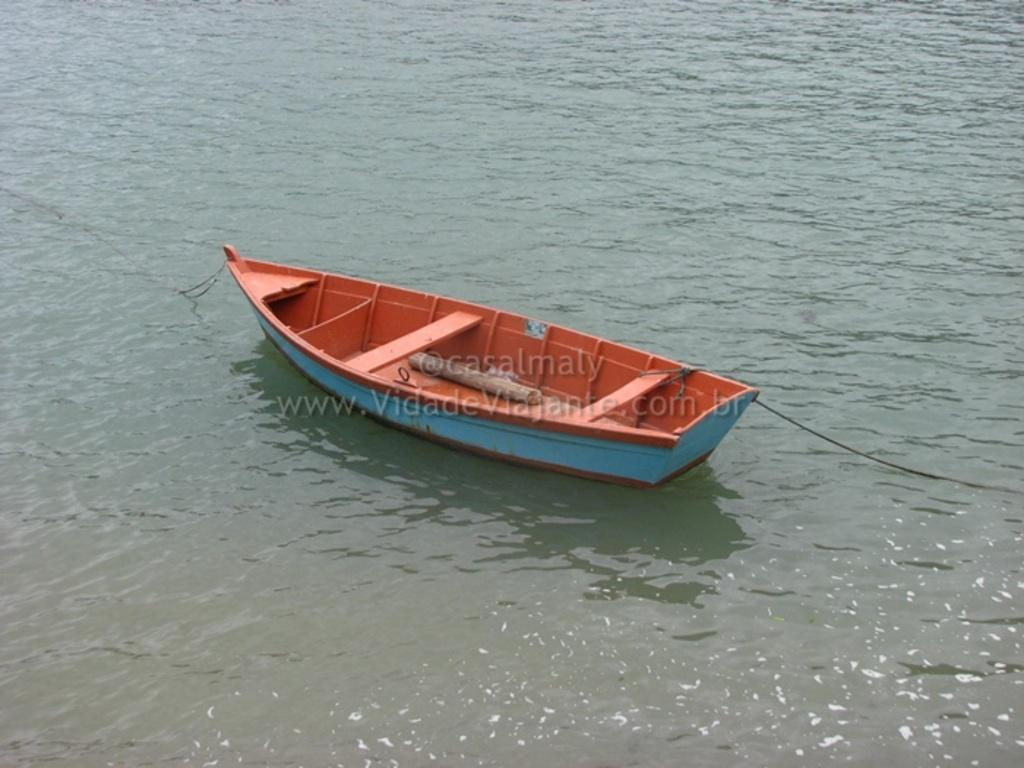What is the main subject of the image? The main subject of the image is a boat in the water. Where is the boat located in the image? The boat is in the center of the image. What else can be seen in the center of the image? There is a watermark in the center of the image. What type of lipstick is being applied on the boat in the image? There is no lipstick or person applying it in the image; it features a boat in the water with a watermark. 